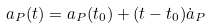Convert formula to latex. <formula><loc_0><loc_0><loc_500><loc_500>a _ { P } ( t ) = a _ { P } ( t _ { 0 } ) + ( t - t _ { 0 } ) \dot { a } _ { P }</formula> 